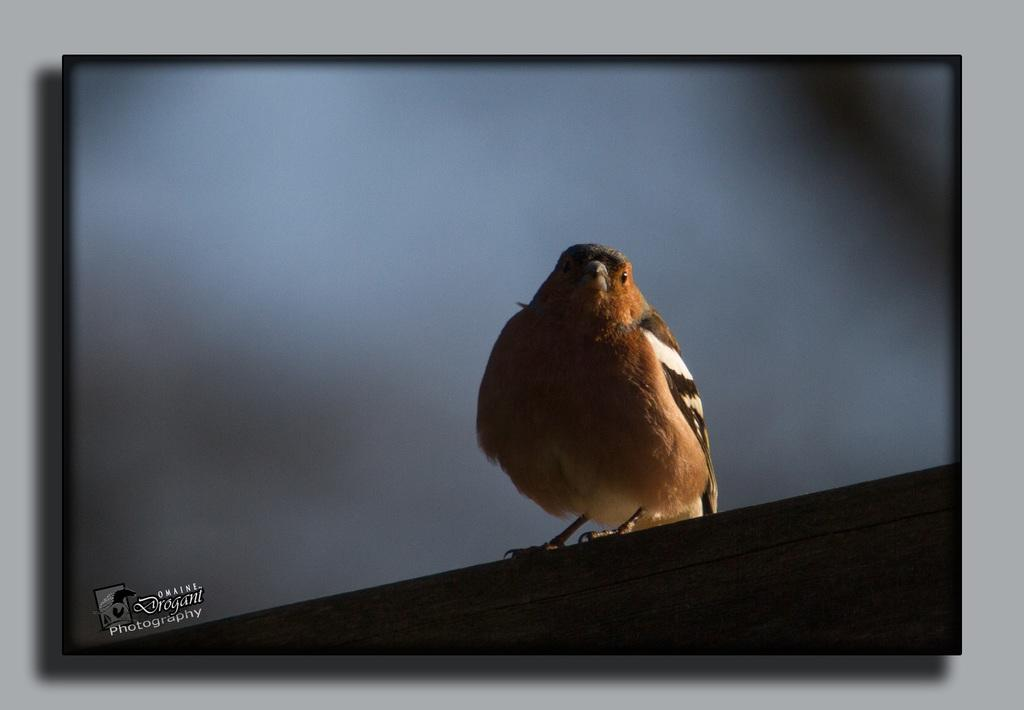What is the main object in the image? There is a monitor in the image. How is the monitor positioned in the image? The monitor is attached to the wall. What can be seen on the monitor's screen? There is a bird displayed on the monitor's screen. Is there any text visible on the monitor's screen? Yes, there is text in the bottom left corner of the monitor's screen. What is the price of the egg shown on the monitor? There is no egg shown on the monitor; it displays a bird and text. How does the brain of the bird on the monitor look? The image on the monitor is not detailed enough to show the bird's brain. 